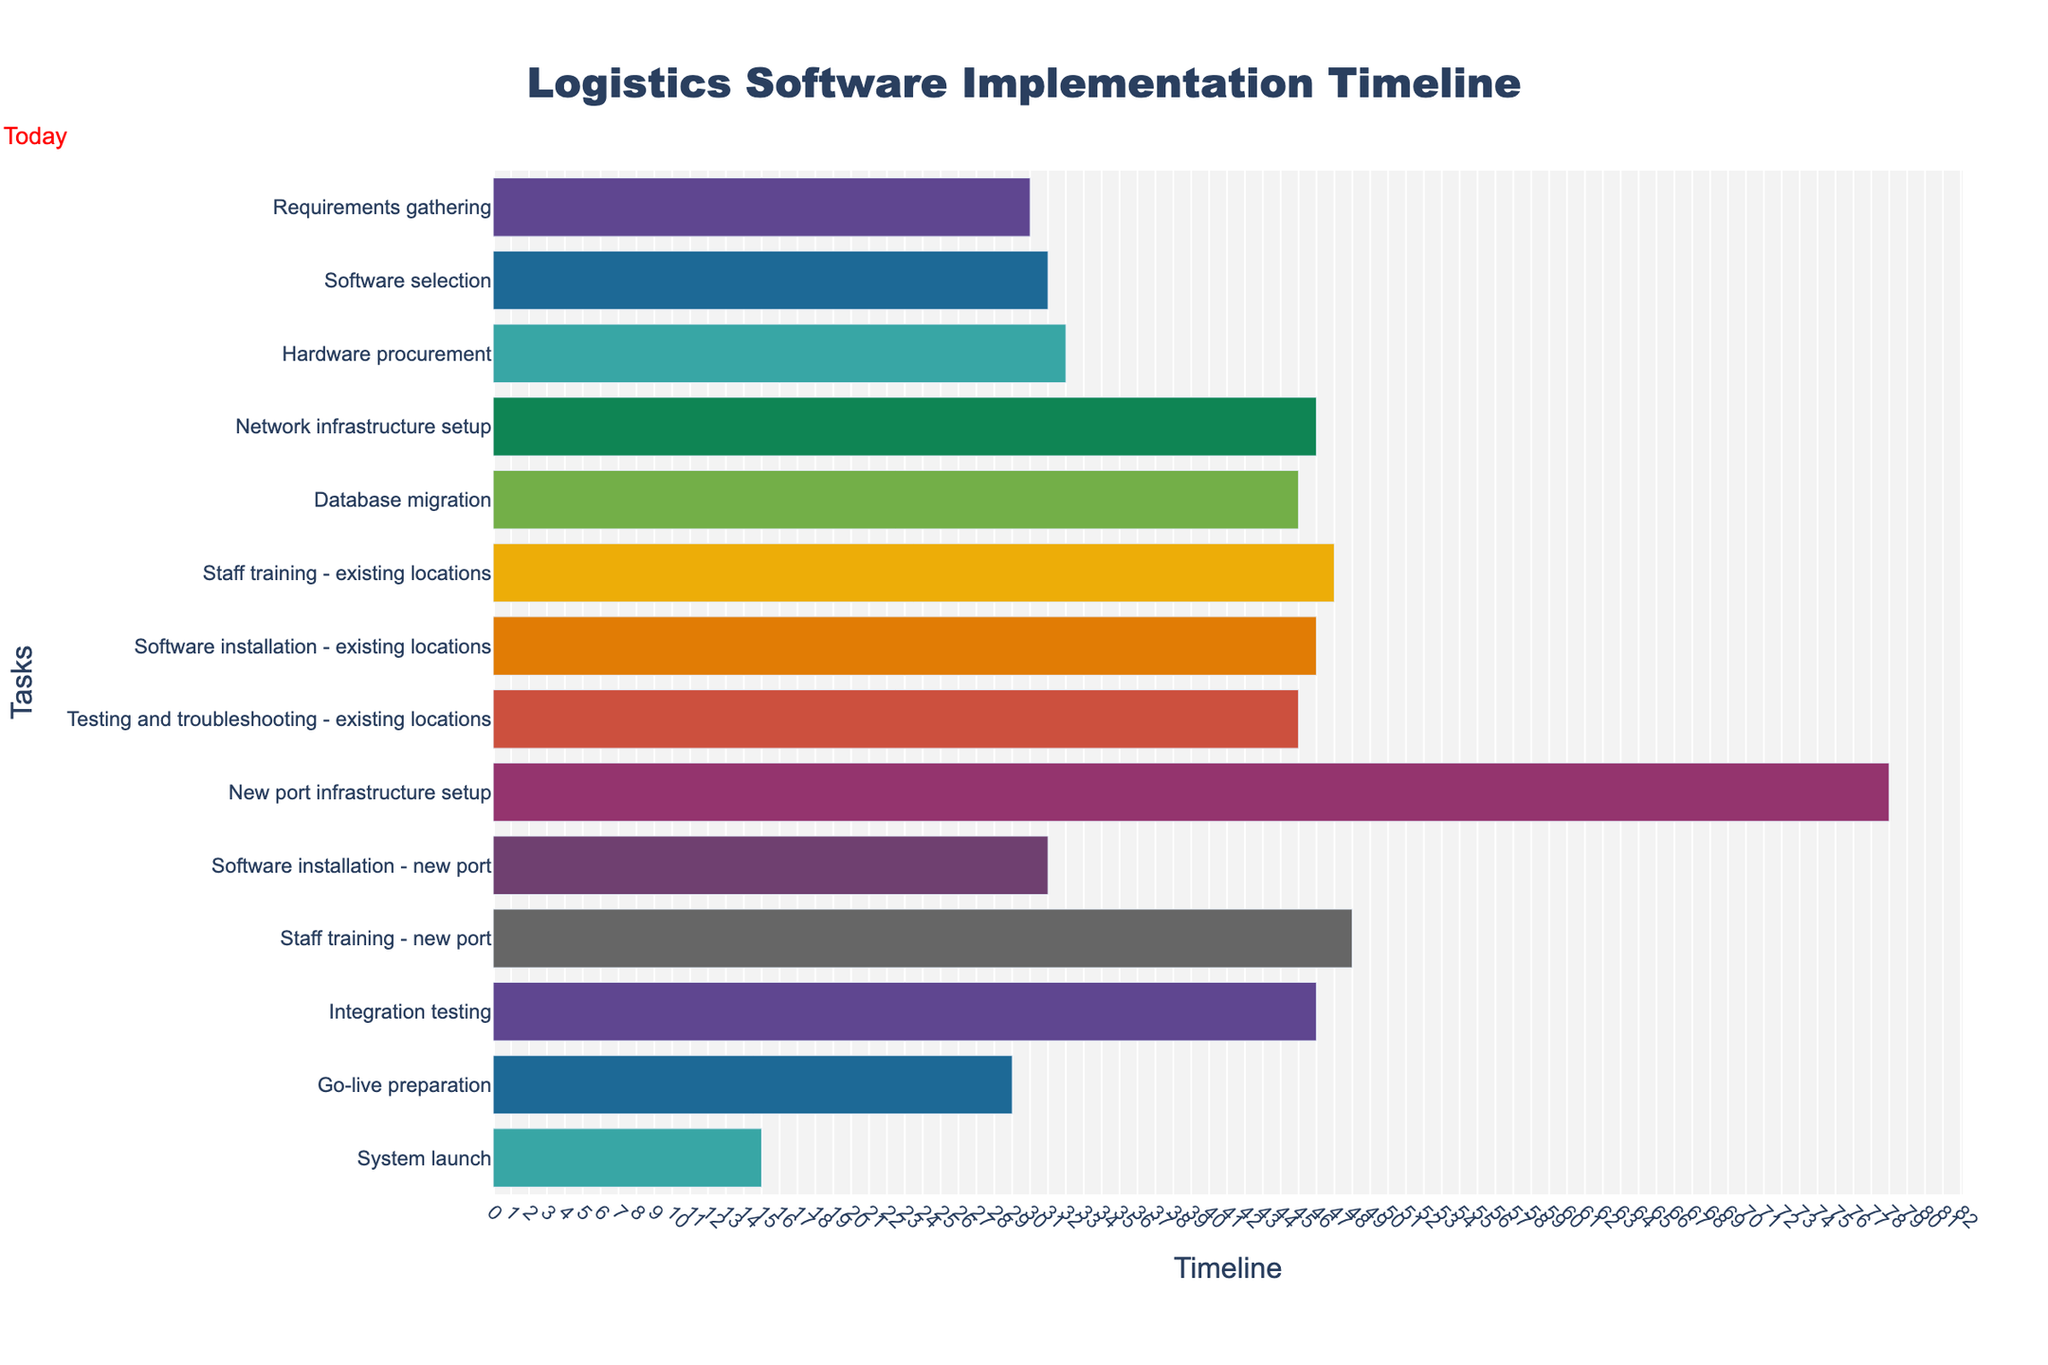What's the project title displayed at the top of the figure? The title of the Gantt chart is the text at the top, which summarizes the purpose of the visualization. It's typically displayed in a larger font size and bold.
Answer: Logistics Software Implementation Timeline What colors are used in the Gantt chart to represent different tasks? The Gantt chart uses a palette from the "Prism" qualitative color scale, which includes a variety of bright colors to differentiate the tasks. The specific colors are not detailed but are visually distinct.
Answer: Various bright colors What's the duration of the "Software installation - existing locations" task? The duration of each task is typically shown in the Gantt chart. For "Software installation - existing locations," it's represented by the width of the corresponding bar and is noted in the duration column.
Answer: 46 days How does the duration of "Software installation - new port" compare to "Software installation - existing locations"? To compare, look at the bar lengths or duration values in the figure. "Software installation - existing" is 46 days, and "Software installation - new port" is 31 days. A comparison reveals the former is longer.
Answer: 46 days vs. 31 days When is the "System launch" scheduled to occur? The "System launch" bar on the Gantt chart extends from its start date to its end date. The task begins on 2024-03-01 and ends on 2024-03-15.
Answer: March 1 to March 15, 2024 Which tasks overlap with the "Database migration" phase? To determine this, locate "Database migration" on the chart, spanning from 2023-09-01 to 2023-10-15. Overlapping tasks have bars that intersect these dates.
Answer: "Staff training - existing locations" and "Network infrastructure setup" How many days before the "System launch" does the "Go-live preparation" start? Find the start date of "Go-live preparation" and the end date of "System launch". Subtract the end date from the start date of the "Go-live preparation" phase. "Go-live preparation" starts on 2024-02-01 and "System launch" ends on 2024-03-15.
Answer: 29 days What's the longest task in the Gantt chart and its duration? By examining the chart, the longest task can be identified by the longest bar. According to the data, "New port infrastructure setup" lasts 78 days, the longest duration among the tasks.
Answer: New port infrastructure setup, 78 days What preparation is visible on the chart for the new port before the system launch? The preparation for the new port includes tasks that mention "new port." From the figure, these tasks are "New port infrastructure setup," "Software installation - new port," and "Staff training - new port."
Answer: Infrastructure setup, software installation, staff training What tasks are planned to start in September 2023? Check the chart for tasks starting in September 2023. "Network infrastructure setup" begins on 2023-09-15, and "Staff training - existing locations" starts on 2023-09-15.
Answer: "Staff training - existing locations" and "Database migration" 